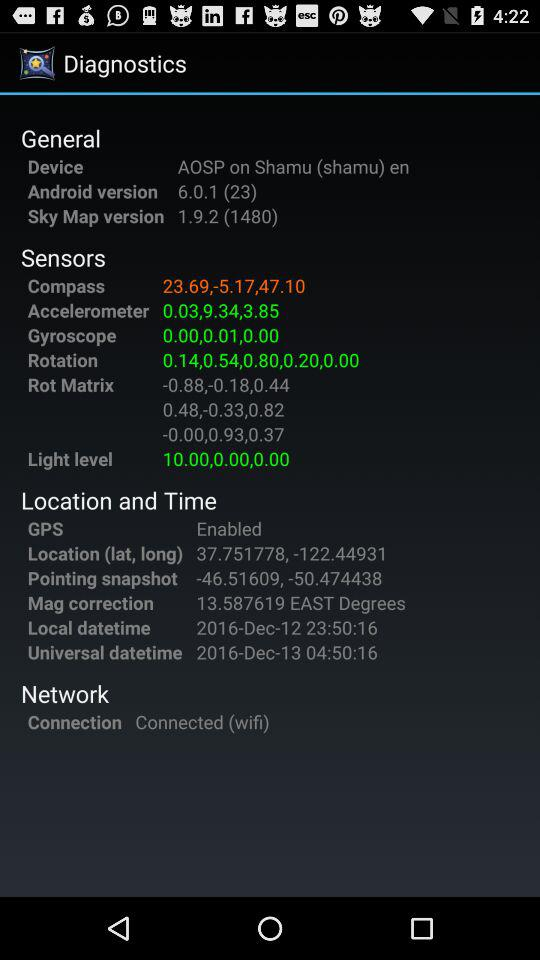What is the "Sky Map" version? The "Sky Map" version is 1.9.2 (1480). 